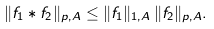<formula> <loc_0><loc_0><loc_500><loc_500>\| f _ { 1 } * f _ { 2 } \| _ { p , A } \leq \| f _ { 1 } \| _ { 1 , A } \, \| f _ { 2 } \| _ { p , A } .</formula> 